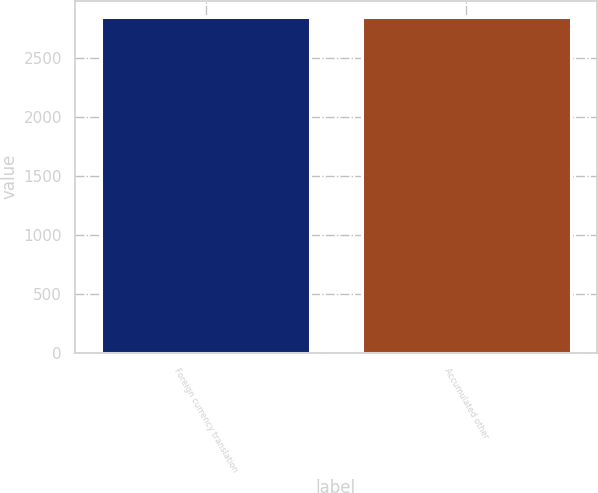Convert chart. <chart><loc_0><loc_0><loc_500><loc_500><bar_chart><fcel>Foreign currency translation<fcel>Accumulated other<nl><fcel>2843<fcel>2843.1<nl></chart> 